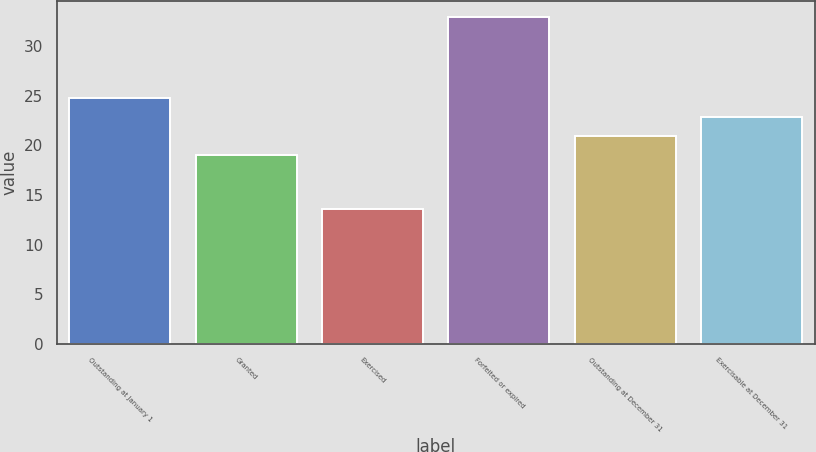Convert chart to OTSL. <chart><loc_0><loc_0><loc_500><loc_500><bar_chart><fcel>Outstanding at January 1<fcel>Granted<fcel>Exercised<fcel>Forfeited or expired<fcel>Outstanding at December 31<fcel>Exercisable at December 31<nl><fcel>24.81<fcel>18.99<fcel>13.59<fcel>32.96<fcel>20.93<fcel>22.87<nl></chart> 